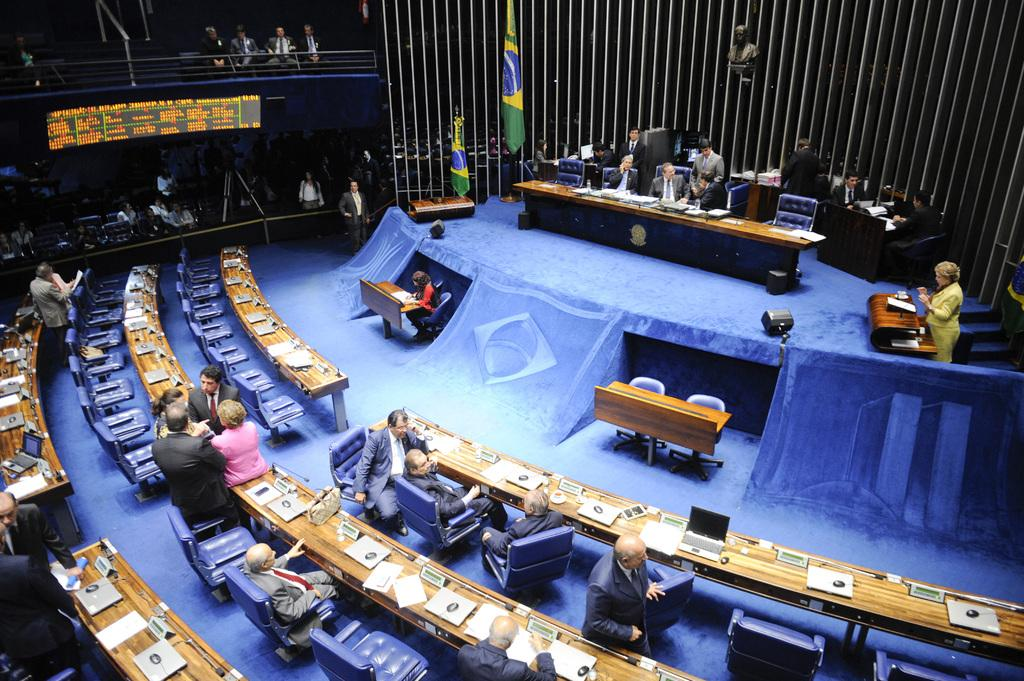What type of furniture can be seen in the image? There are chairs and tables in the image. What are the people in the image doing? Some people are seated, while others are standing in the image. What decorative elements are present in the image? There are flags in the image. What can be used for displaying information or announcements? There is a display board in the image. How many beans are present on the display board in the image? There are no beans mentioned or visible on the display board in the image. Can you describe the frog that is standing near the chairs in the image? There is no frog present near the chairs in the image. 